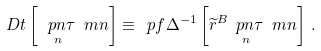Convert formula to latex. <formula><loc_0><loc_0><loc_500><loc_500>\ D t \left [ \, \underset { n } { \ p n { \tau } } \ m n \right ] \equiv \ p f \Delta ^ { - 1 } \left [ { \widetilde { r } } ^ { B } \underset { n } { \ p n { \tau } } \ m n \right ] \, .</formula> 